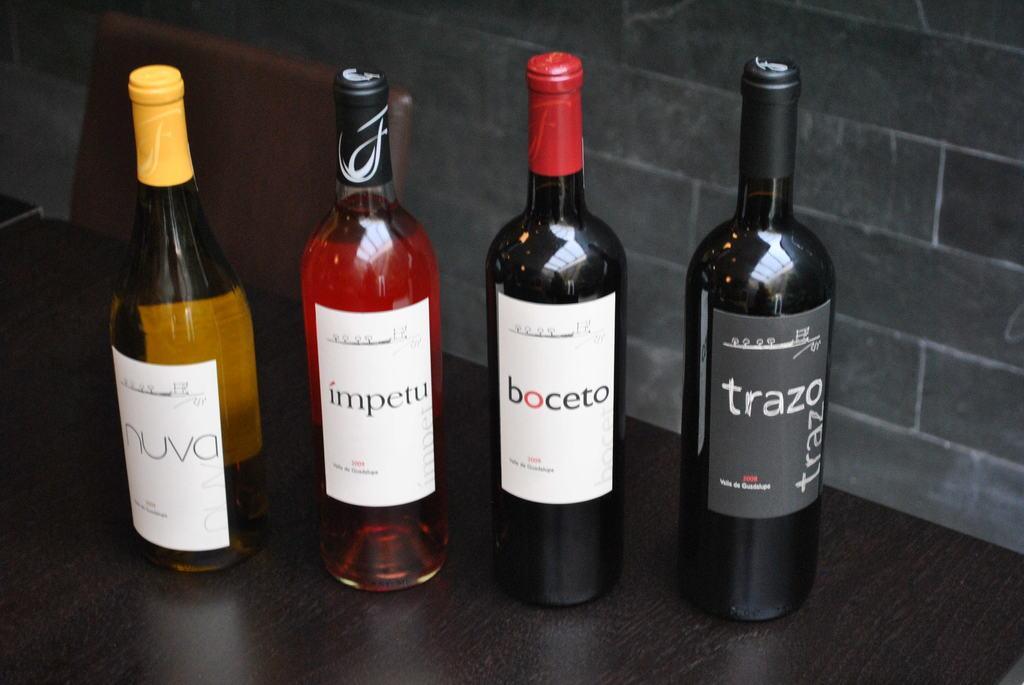Please provide a concise description of this image. In this image I can see there are four glass bottles. 